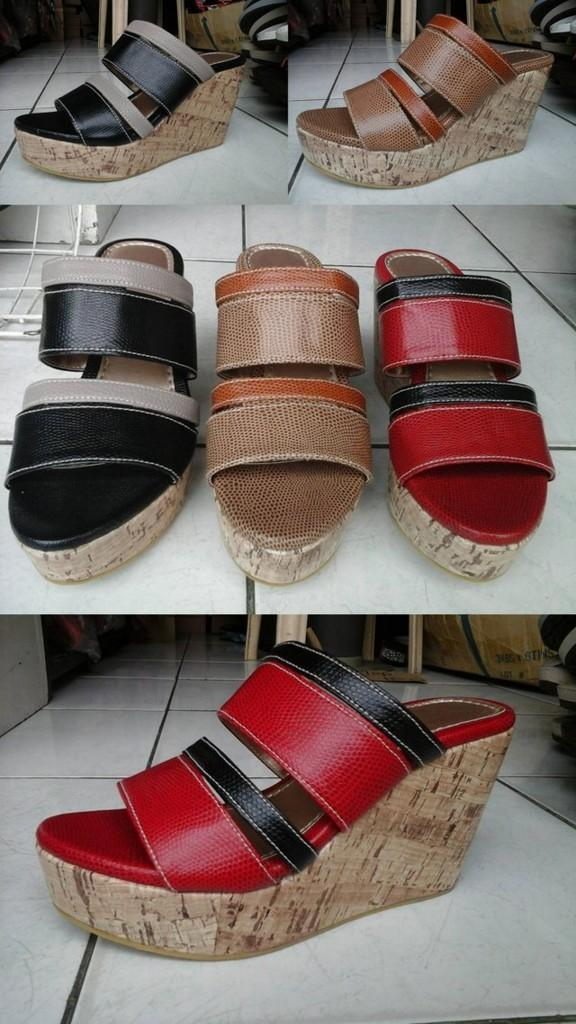What is the format of the image? The image is a collage of different pictures. What is a common element in all the pictures in the collage? All the pictures in the collage contain wedges. Can you see any squirrels in the image? There are no squirrels present in the image; the collage only contains pictures of wedges. How many times do the wedges turn in the image? The wedges in the image do not turn; they are stationary in the pictures. 